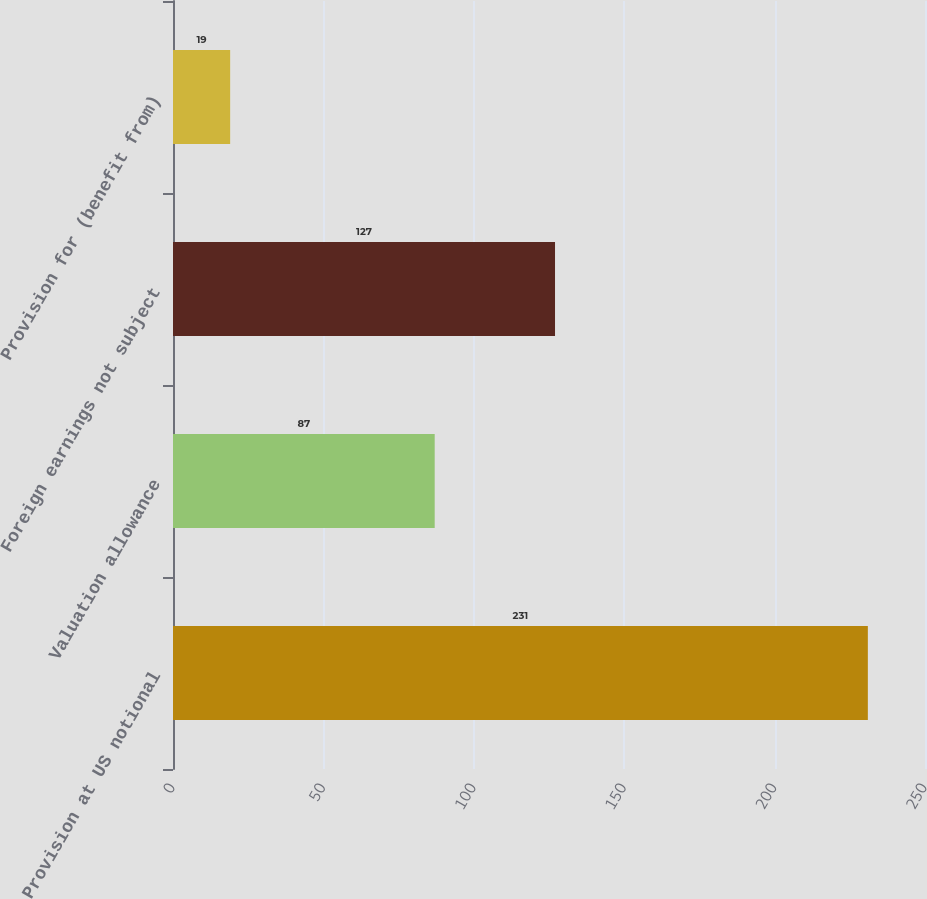<chart> <loc_0><loc_0><loc_500><loc_500><bar_chart><fcel>Provision at US notional<fcel>Valuation allowance<fcel>Foreign earnings not subject<fcel>Provision for (benefit from)<nl><fcel>231<fcel>87<fcel>127<fcel>19<nl></chart> 